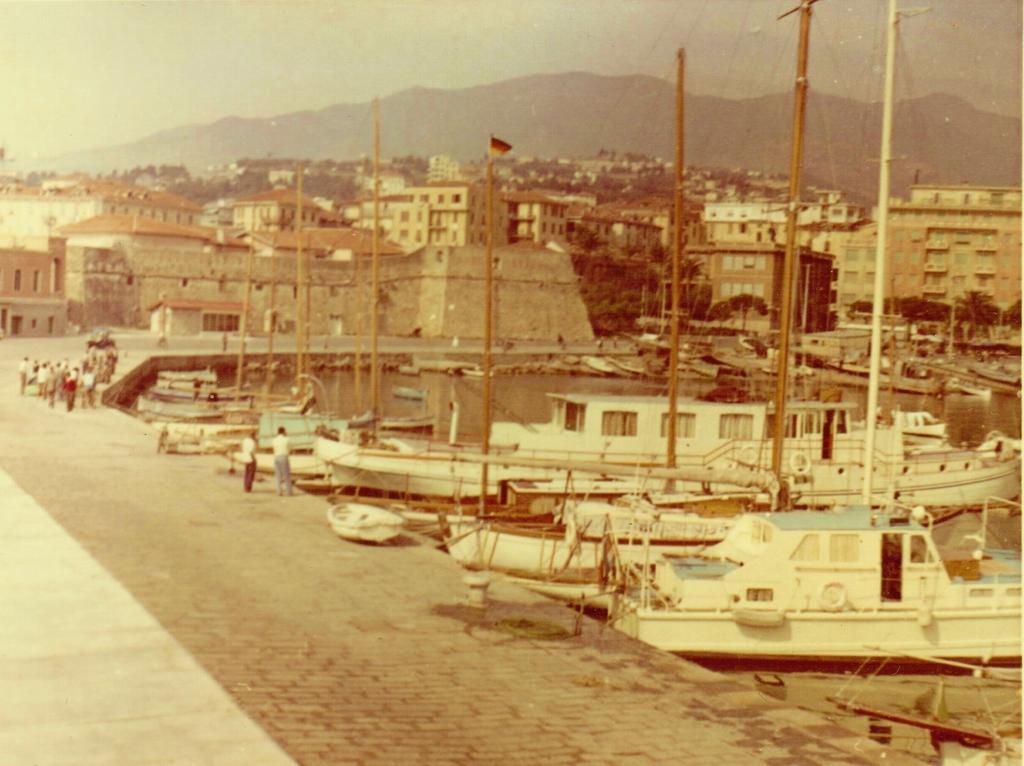Please provide a concise description of this image. In the image in the center we can see few boats,which is in white color. In the background we can see sky,buildings,wall,roof,road,water,flag,boats and group of people were standing. 